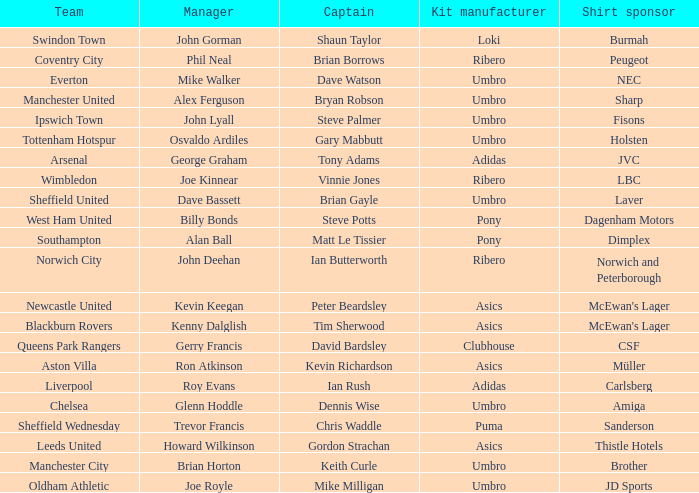Which captain has billy bonds as the manager? Steve Potts. Parse the full table. {'header': ['Team', 'Manager', 'Captain', 'Kit manufacturer', 'Shirt sponsor'], 'rows': [['Swindon Town', 'John Gorman', 'Shaun Taylor', 'Loki', 'Burmah'], ['Coventry City', 'Phil Neal', 'Brian Borrows', 'Ribero', 'Peugeot'], ['Everton', 'Mike Walker', 'Dave Watson', 'Umbro', 'NEC'], ['Manchester United', 'Alex Ferguson', 'Bryan Robson', 'Umbro', 'Sharp'], ['Ipswich Town', 'John Lyall', 'Steve Palmer', 'Umbro', 'Fisons'], ['Tottenham Hotspur', 'Osvaldo Ardiles', 'Gary Mabbutt', 'Umbro', 'Holsten'], ['Arsenal', 'George Graham', 'Tony Adams', 'Adidas', 'JVC'], ['Wimbledon', 'Joe Kinnear', 'Vinnie Jones', 'Ribero', 'LBC'], ['Sheffield United', 'Dave Bassett', 'Brian Gayle', 'Umbro', 'Laver'], ['West Ham United', 'Billy Bonds', 'Steve Potts', 'Pony', 'Dagenham Motors'], ['Southampton', 'Alan Ball', 'Matt Le Tissier', 'Pony', 'Dimplex'], ['Norwich City', 'John Deehan', 'Ian Butterworth', 'Ribero', 'Norwich and Peterborough'], ['Newcastle United', 'Kevin Keegan', 'Peter Beardsley', 'Asics', "McEwan's Lager"], ['Blackburn Rovers', 'Kenny Dalglish', 'Tim Sherwood', 'Asics', "McEwan's Lager"], ['Queens Park Rangers', 'Gerry Francis', 'David Bardsley', 'Clubhouse', 'CSF'], ['Aston Villa', 'Ron Atkinson', 'Kevin Richardson', 'Asics', 'Müller'], ['Liverpool', 'Roy Evans', 'Ian Rush', 'Adidas', 'Carlsberg'], ['Chelsea', 'Glenn Hoddle', 'Dennis Wise', 'Umbro', 'Amiga'], ['Sheffield Wednesday', 'Trevor Francis', 'Chris Waddle', 'Puma', 'Sanderson'], ['Leeds United', 'Howard Wilkinson', 'Gordon Strachan', 'Asics', 'Thistle Hotels'], ['Manchester City', 'Brian Horton', 'Keith Curle', 'Umbro', 'Brother'], ['Oldham Athletic', 'Joe Royle', 'Mike Milligan', 'Umbro', 'JD Sports']]} 